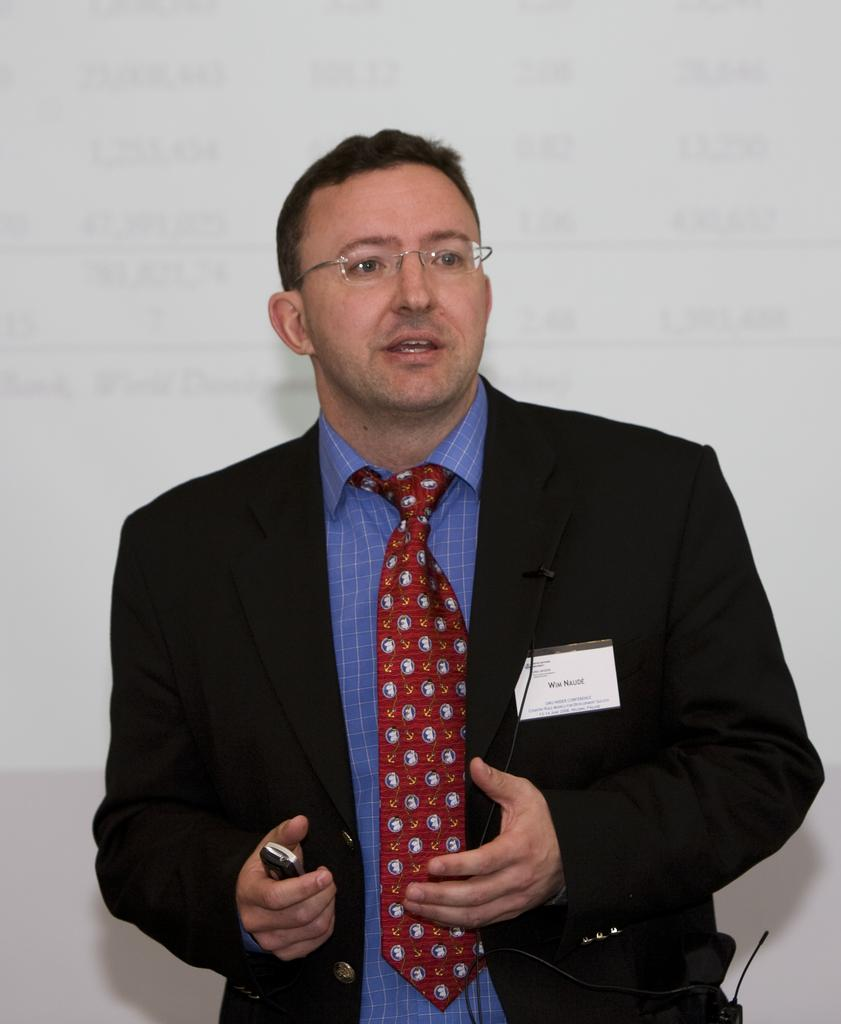What can be seen in the image? There is a person in the image. What is the person holding? The person is holding an object. What else is visible in the image? There is a screen visible in the image. What type of amusement can be seen on the bed in the image? There is no bed or amusement present in the image. 